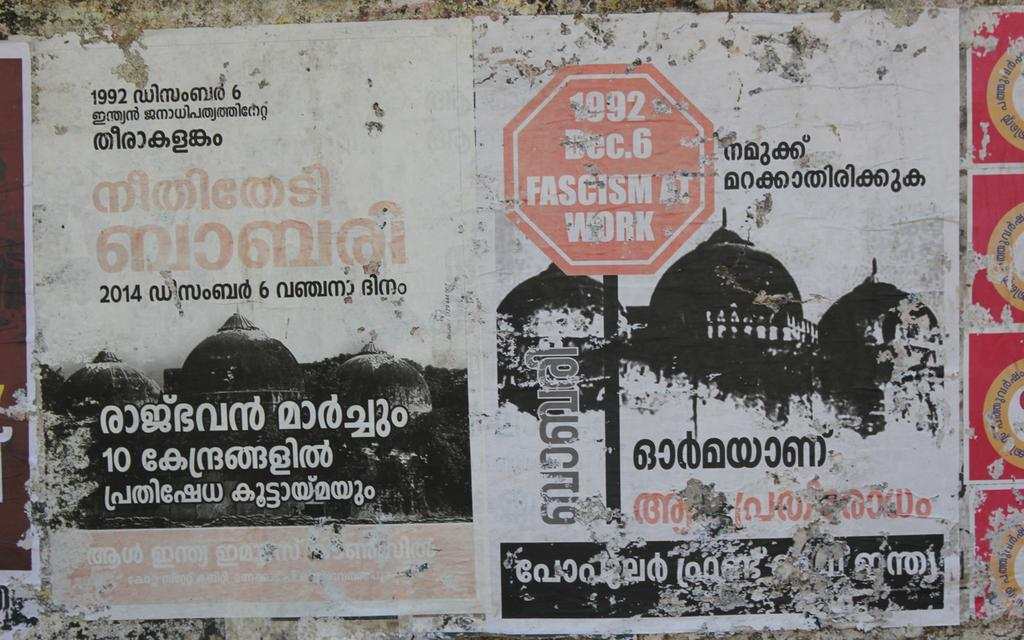<image>
Render a clear and concise summary of the photo. An old paper has an image of a red stop sign with the words "fascism at work" on it. 